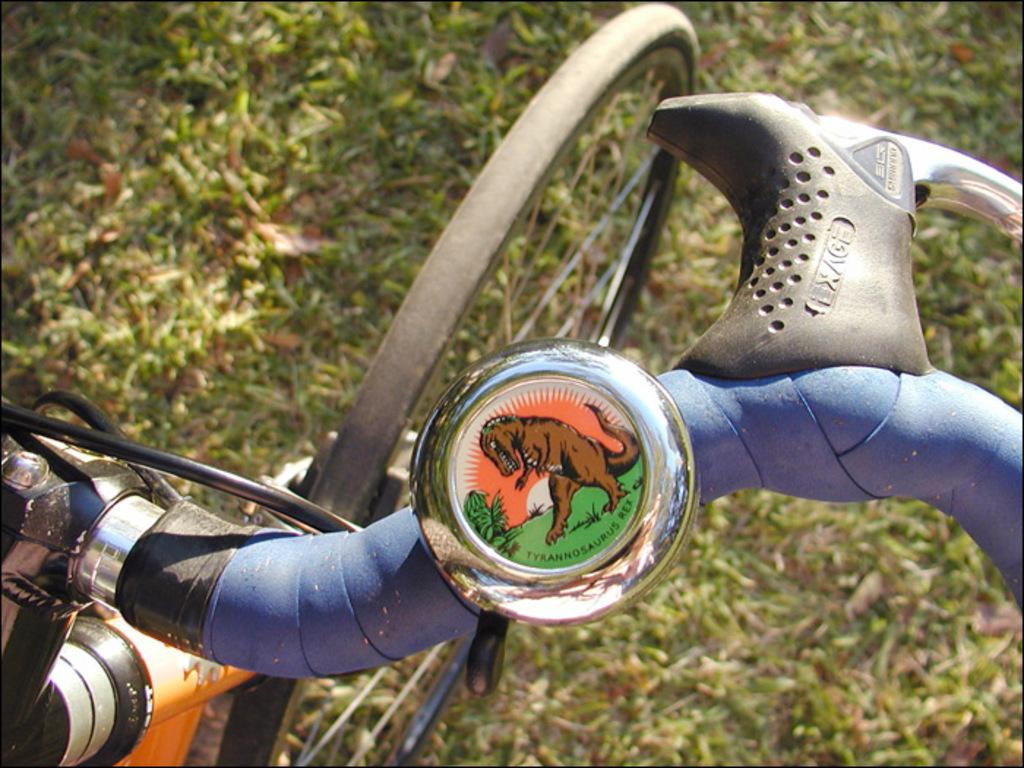What is the main object in the image? There is a bicycle in the image. Where is the bicycle located? The bicycle is on the grass. What type of bait is being used to catch fish in the image? There is no mention of fishing or bait in the image; it features a bicycle on the grass. 